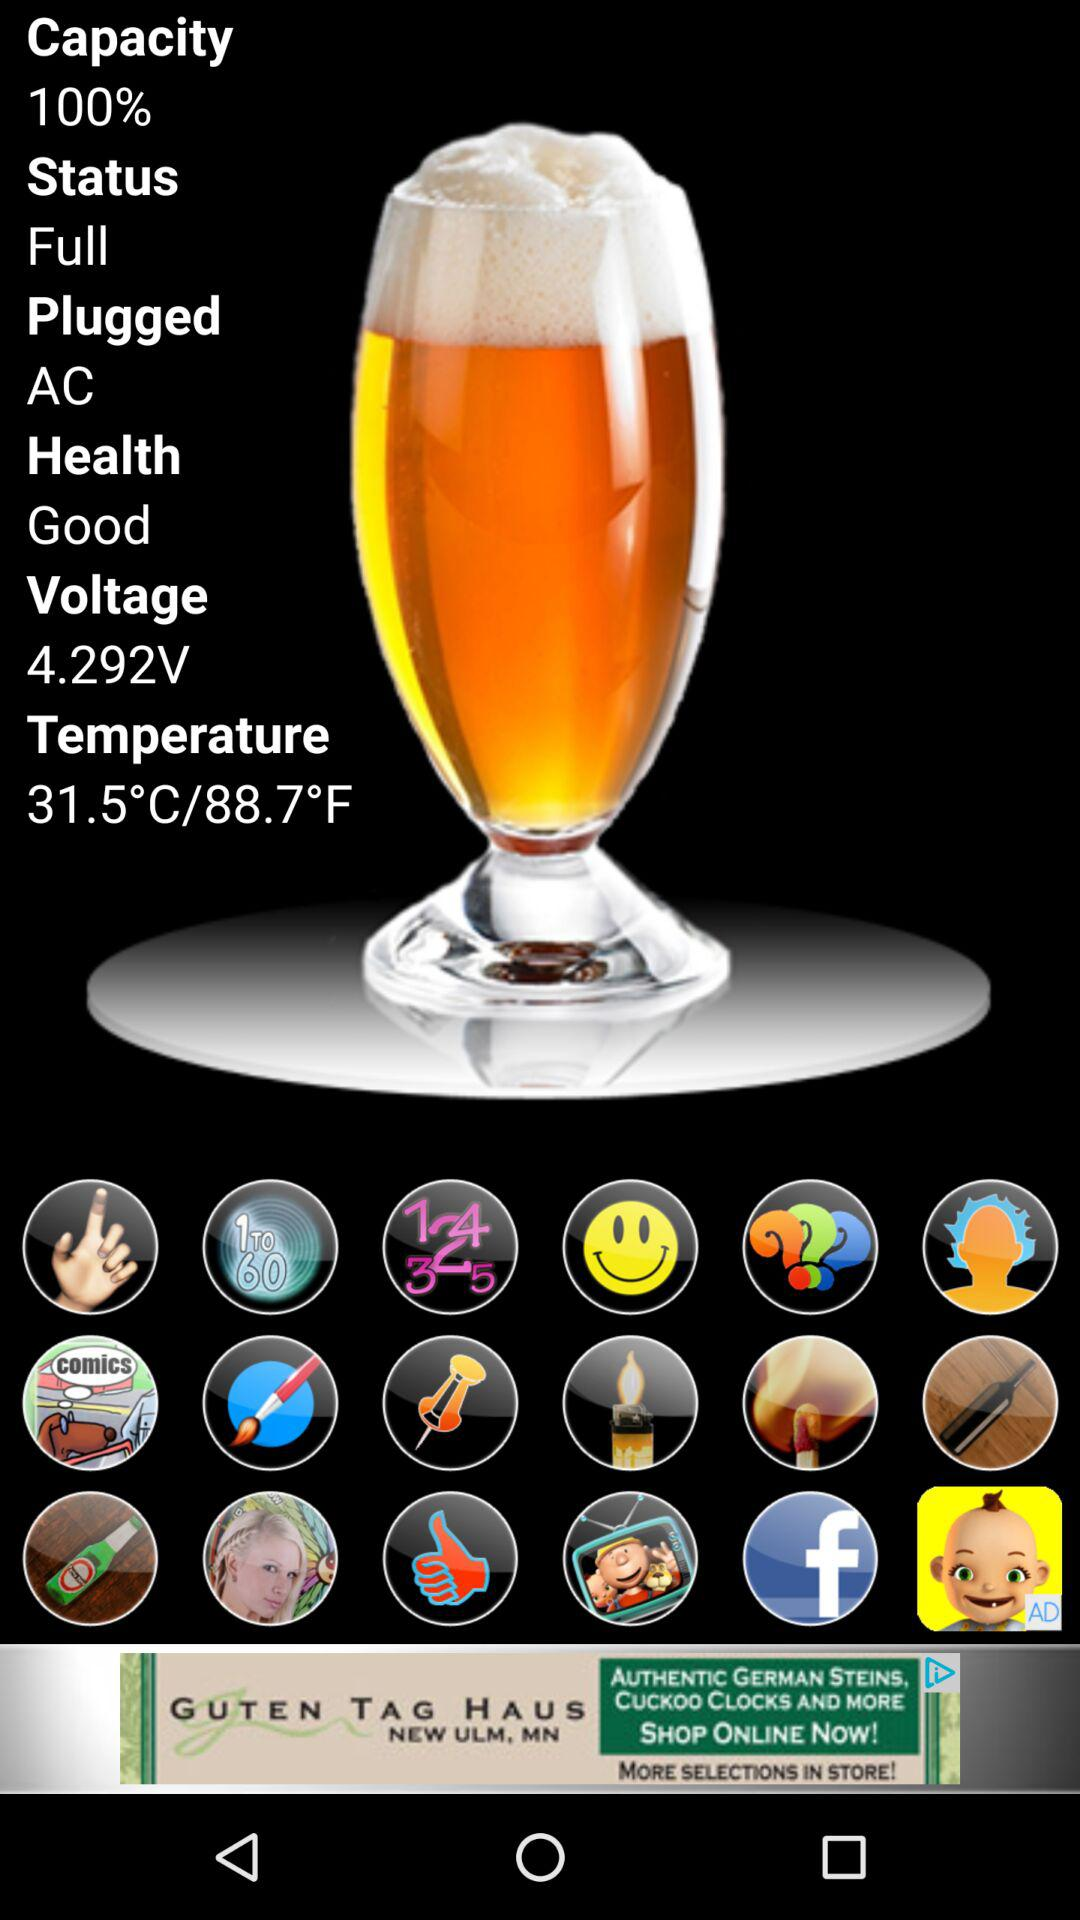What is the voltage? The voltage is 4.292 V. 